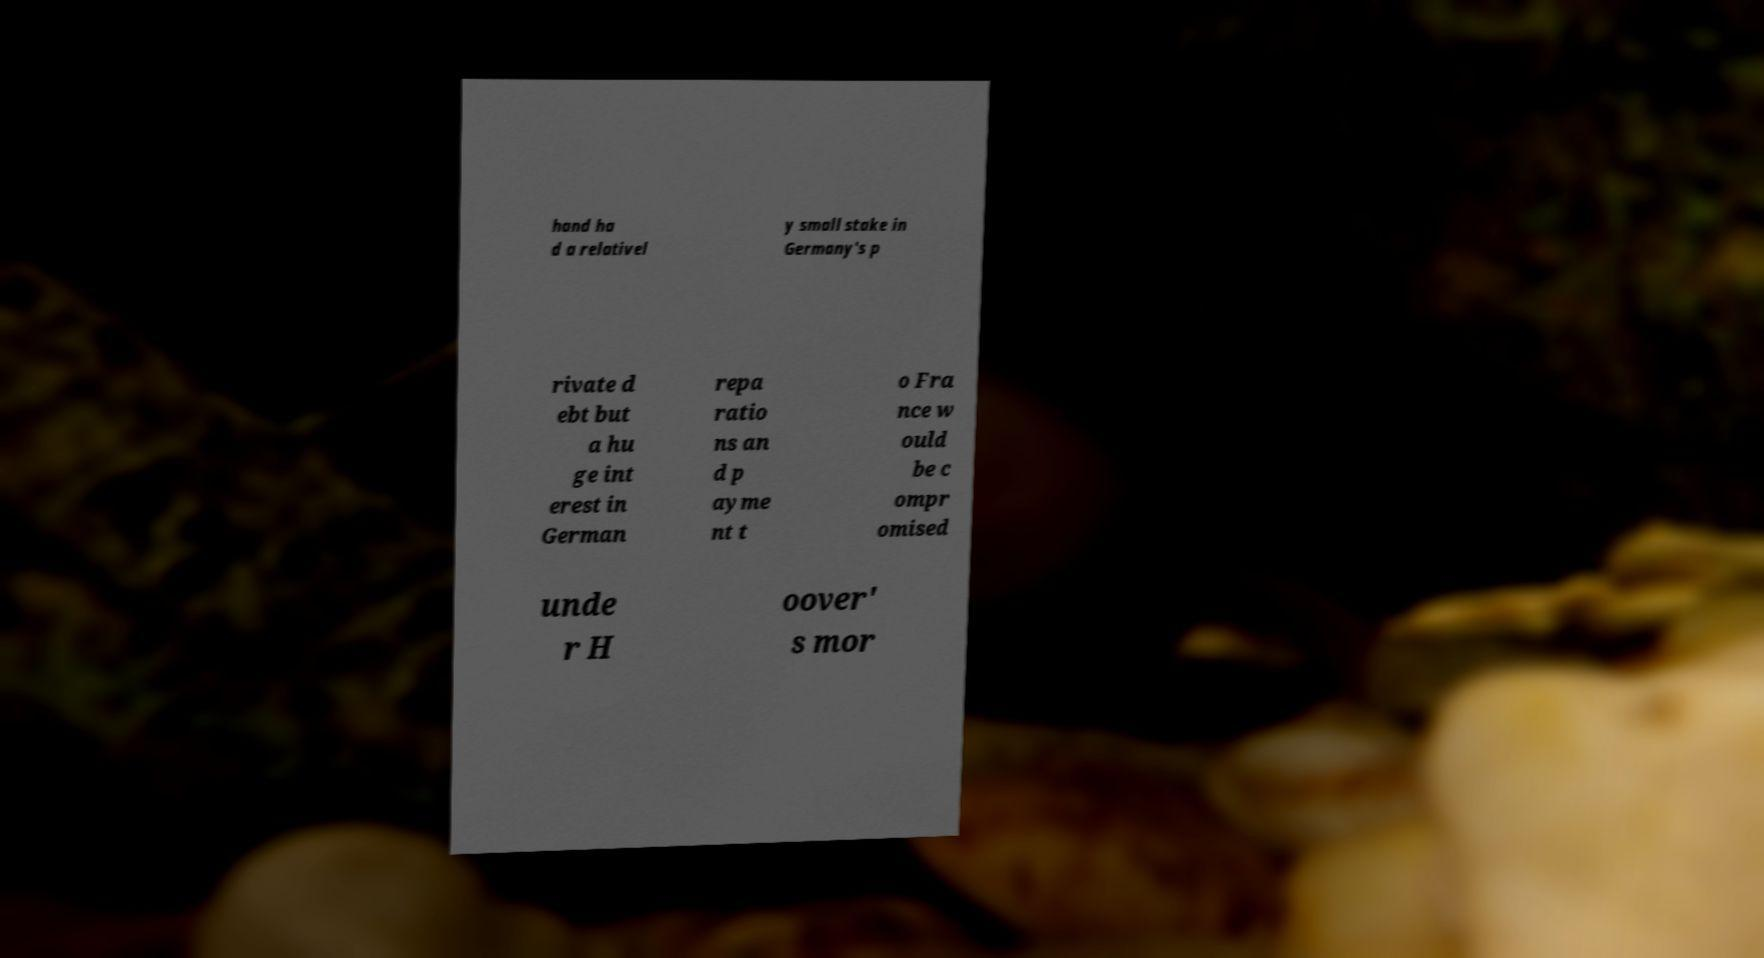Could you assist in decoding the text presented in this image and type it out clearly? hand ha d a relativel y small stake in Germany's p rivate d ebt but a hu ge int erest in German repa ratio ns an d p ayme nt t o Fra nce w ould be c ompr omised unde r H oover' s mor 